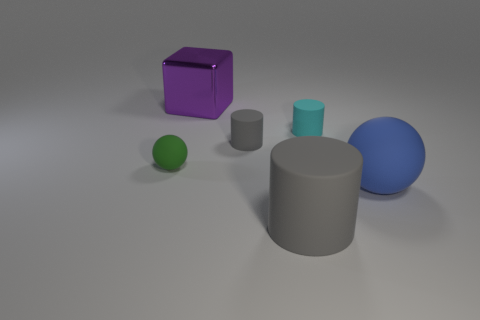Subtract all small cyan cylinders. How many cylinders are left? 2 Subtract all gray cylinders. How many cylinders are left? 1 Subtract all large cubes. Subtract all small green things. How many objects are left? 4 Add 3 blocks. How many blocks are left? 4 Add 1 small cyan rubber cylinders. How many small cyan rubber cylinders exist? 2 Add 1 large blue rubber things. How many objects exist? 7 Subtract 0 red cylinders. How many objects are left? 6 Subtract all spheres. How many objects are left? 4 Subtract 1 cylinders. How many cylinders are left? 2 Subtract all brown cylinders. Subtract all purple spheres. How many cylinders are left? 3 